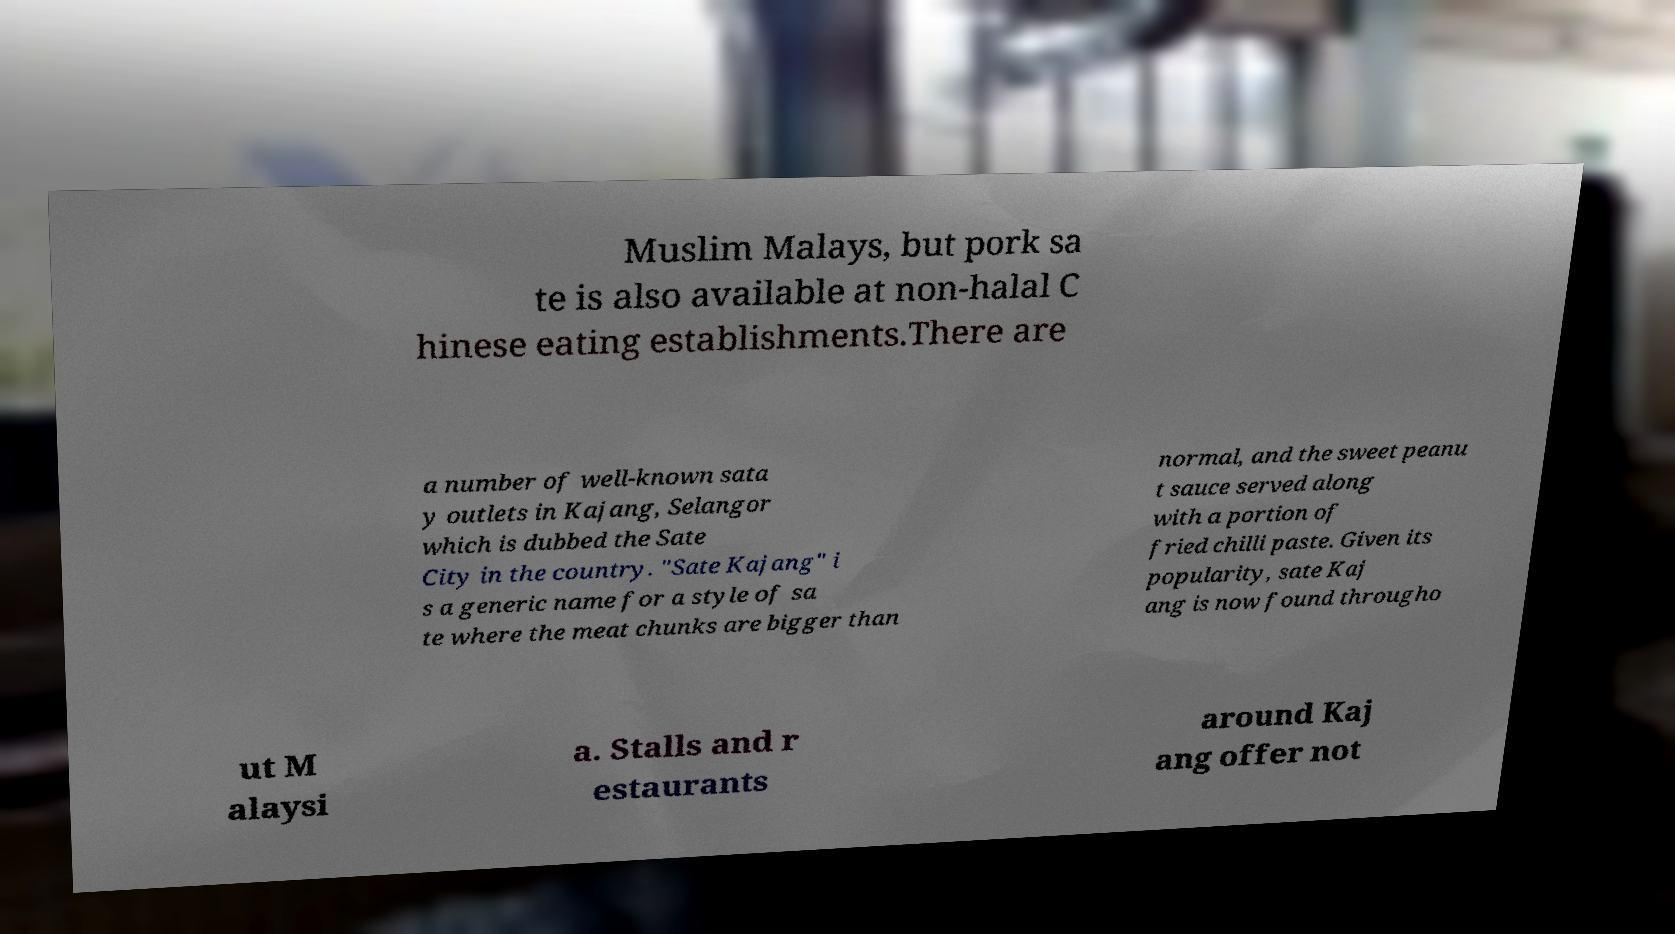Could you assist in decoding the text presented in this image and type it out clearly? Muslim Malays, but pork sa te is also available at non-halal C hinese eating establishments.There are a number of well-known sata y outlets in Kajang, Selangor which is dubbed the Sate City in the country. "Sate Kajang" i s a generic name for a style of sa te where the meat chunks are bigger than normal, and the sweet peanu t sauce served along with a portion of fried chilli paste. Given its popularity, sate Kaj ang is now found througho ut M alaysi a. Stalls and r estaurants around Kaj ang offer not 